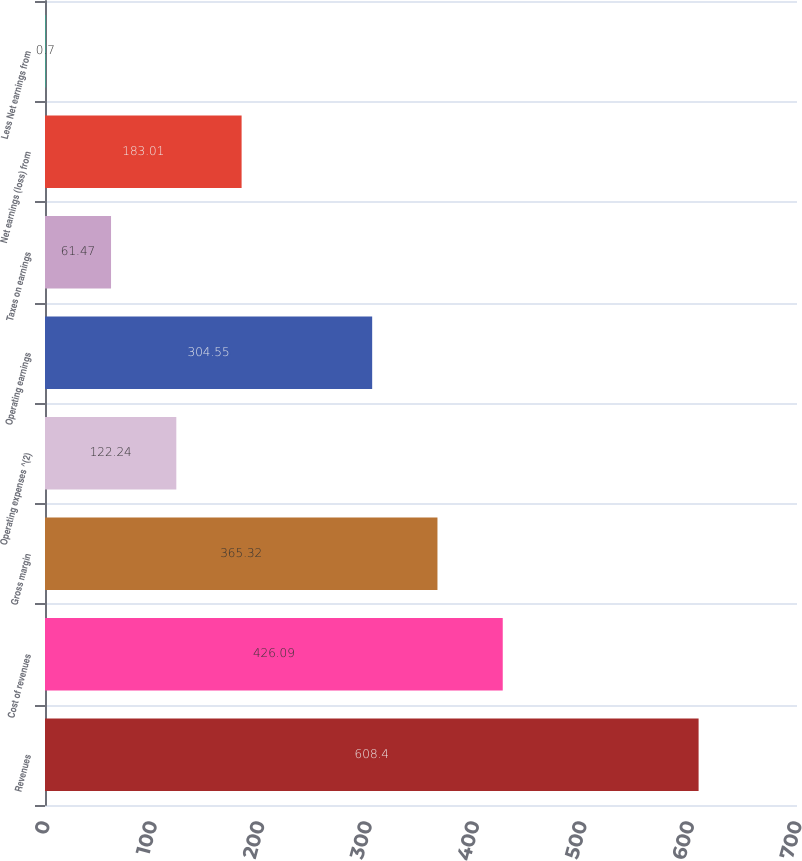<chart> <loc_0><loc_0><loc_500><loc_500><bar_chart><fcel>Revenues<fcel>Cost of revenues<fcel>Gross margin<fcel>Operating expenses ^(2)<fcel>Operating earnings<fcel>Taxes on earnings<fcel>Net earnings (loss) from<fcel>Less Net earnings from<nl><fcel>608.4<fcel>426.09<fcel>365.32<fcel>122.24<fcel>304.55<fcel>61.47<fcel>183.01<fcel>0.7<nl></chart> 